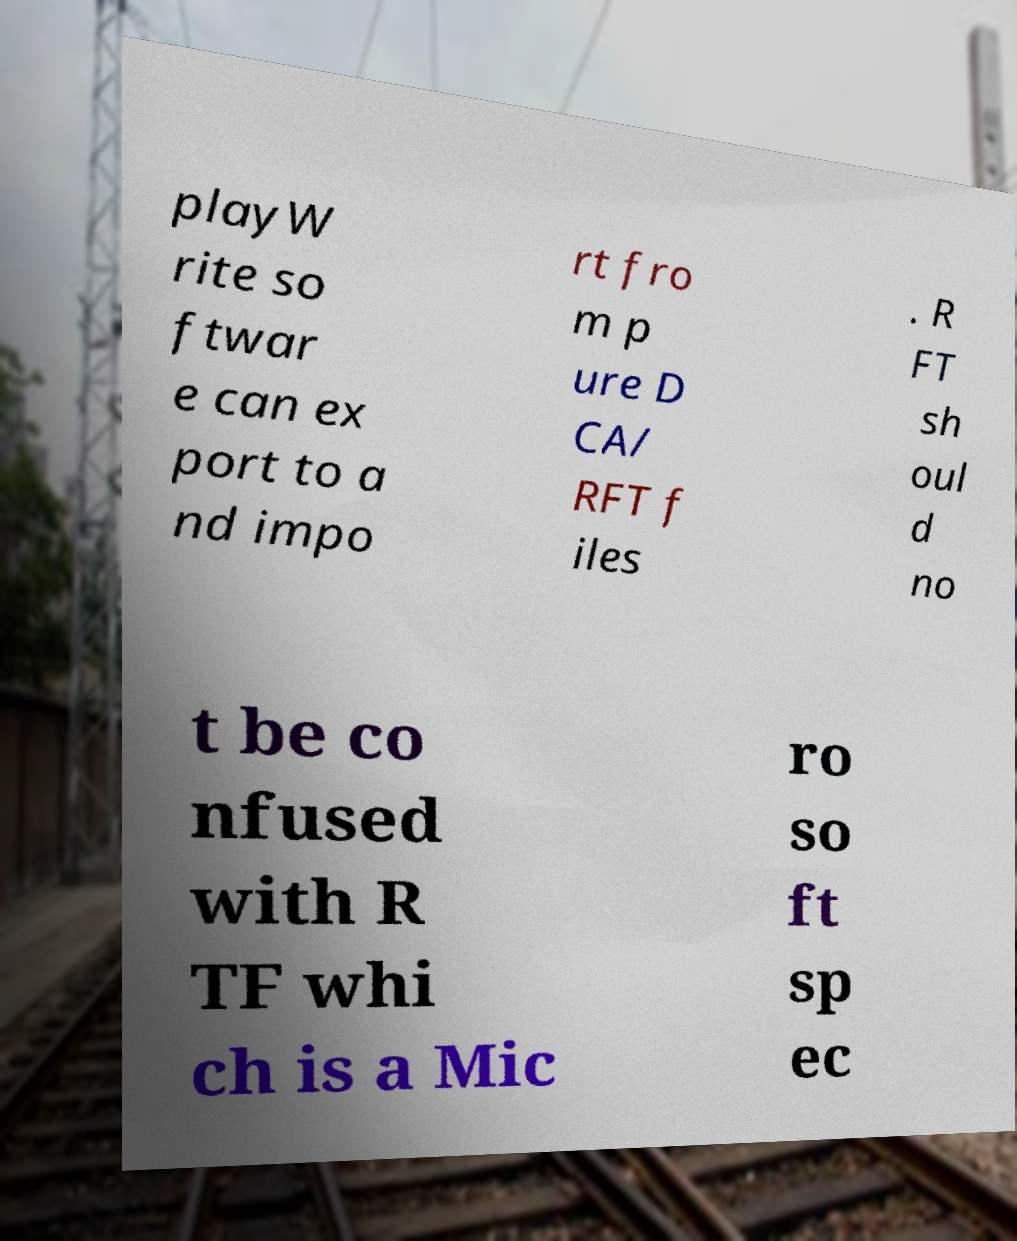Can you read and provide the text displayed in the image?This photo seems to have some interesting text. Can you extract and type it out for me? playW rite so ftwar e can ex port to a nd impo rt fro m p ure D CA/ RFT f iles . R FT sh oul d no t be co nfused with R TF whi ch is a Mic ro so ft sp ec 